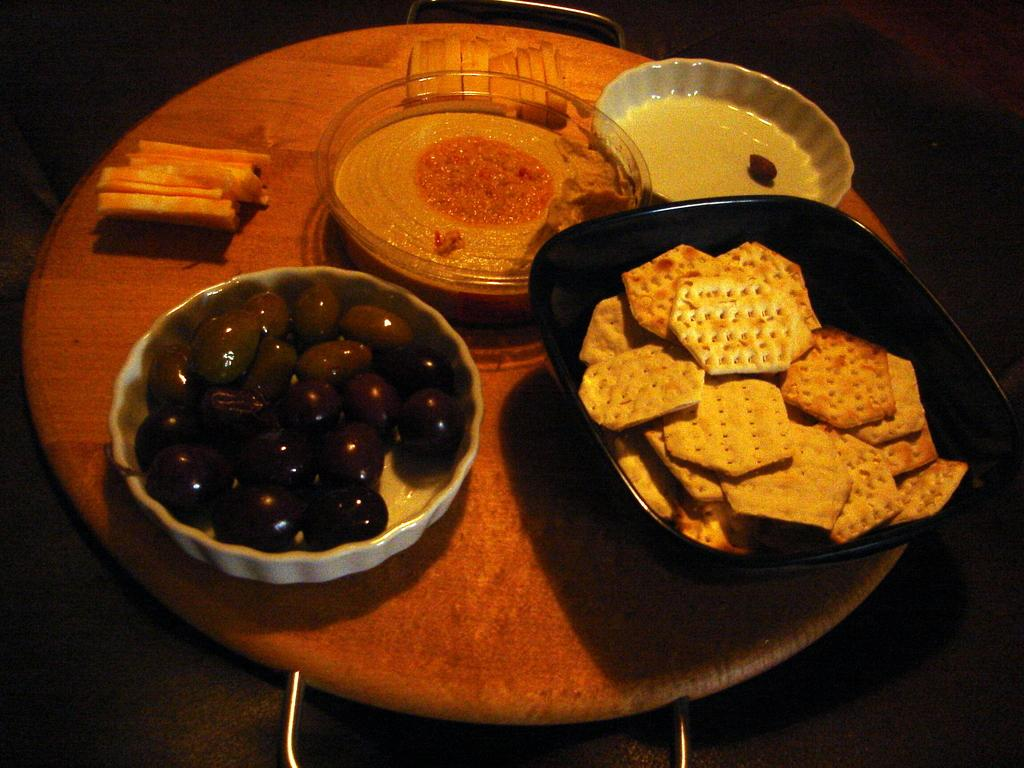What objects are present in the image that can hold food or other items? There are bowls in the image that can hold food or other items. What is inside the bowls? The bowls contain eatable items. Where are the bowls located in the image? The bowls are placed on a table. What type of plane can be seen flying over the waves in the image? There is no plane or waves present in the image; it only features bowls containing eatable items placed on a table. 